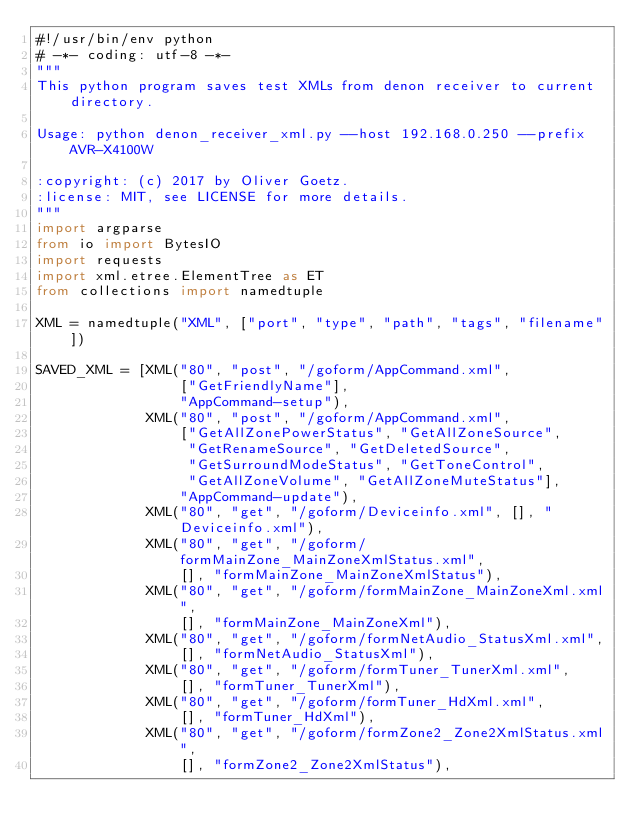Convert code to text. <code><loc_0><loc_0><loc_500><loc_500><_Python_>#!/usr/bin/env python
# -*- coding: utf-8 -*-
"""
This python program saves test XMLs from denon receiver to current directory.

Usage: python denon_receiver_xml.py --host 192.168.0.250 --prefix AVR-X4100W

:copyright: (c) 2017 by Oliver Goetz.
:license: MIT, see LICENSE for more details.
"""
import argparse
from io import BytesIO
import requests
import xml.etree.ElementTree as ET
from collections import namedtuple

XML = namedtuple("XML", ["port", "type", "path", "tags", "filename"])

SAVED_XML = [XML("80", "post", "/goform/AppCommand.xml",
                 ["GetFriendlyName"],
                 "AppCommand-setup"),
             XML("80", "post", "/goform/AppCommand.xml",
                 ["GetAllZonePowerStatus", "GetAllZoneSource",
                  "GetRenameSource", "GetDeletedSource",
                  "GetSurroundModeStatus", "GetToneControl",
                  "GetAllZoneVolume", "GetAllZoneMuteStatus"],
                 "AppCommand-update"),
             XML("80", "get", "/goform/Deviceinfo.xml", [], "Deviceinfo.xml"),
             XML("80", "get", "/goform/formMainZone_MainZoneXmlStatus.xml",
                 [], "formMainZone_MainZoneXmlStatus"),
             XML("80", "get", "/goform/formMainZone_MainZoneXml.xml",
                 [], "formMainZone_MainZoneXml"),
             XML("80", "get", "/goform/formNetAudio_StatusXml.xml",
                 [], "formNetAudio_StatusXml"),
             XML("80", "get", "/goform/formTuner_TunerXml.xml",
                 [], "formTuner_TunerXml"),
             XML("80", "get", "/goform/formTuner_HdXml.xml",
                 [], "formTuner_HdXml"),
             XML("80", "get", "/goform/formZone2_Zone2XmlStatus.xml",
                 [], "formZone2_Zone2XmlStatus"),</code> 